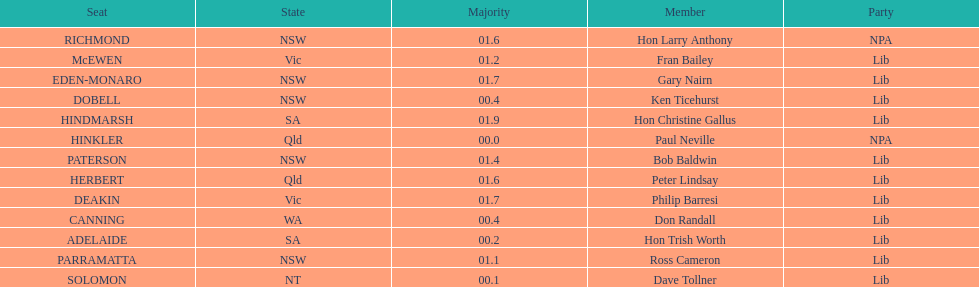Who is the member succeeding hon trish worth? Don Randall. 